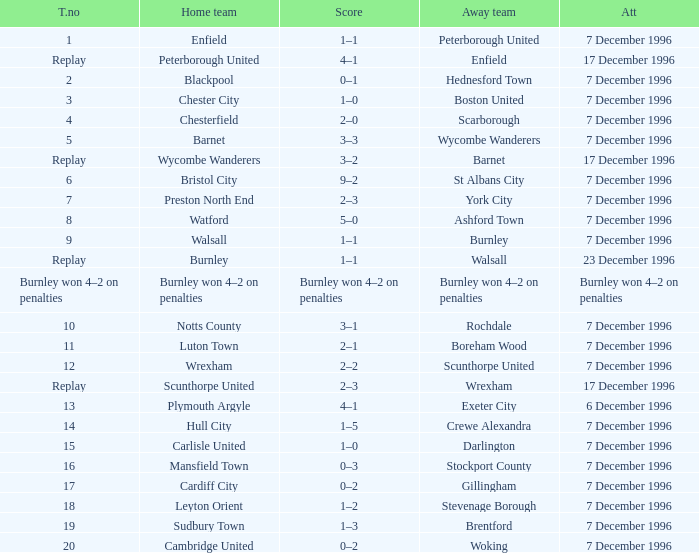What was the attendance for the home team of Walsall? 7 December 1996. Could you parse the entire table? {'header': ['T.no', 'Home team', 'Score', 'Away team', 'Att'], 'rows': [['1', 'Enfield', '1–1', 'Peterborough United', '7 December 1996'], ['Replay', 'Peterborough United', '4–1', 'Enfield', '17 December 1996'], ['2', 'Blackpool', '0–1', 'Hednesford Town', '7 December 1996'], ['3', 'Chester City', '1–0', 'Boston United', '7 December 1996'], ['4', 'Chesterfield', '2–0', 'Scarborough', '7 December 1996'], ['5', 'Barnet', '3–3', 'Wycombe Wanderers', '7 December 1996'], ['Replay', 'Wycombe Wanderers', '3–2', 'Barnet', '17 December 1996'], ['6', 'Bristol City', '9–2', 'St Albans City', '7 December 1996'], ['7', 'Preston North End', '2–3', 'York City', '7 December 1996'], ['8', 'Watford', '5–0', 'Ashford Town', '7 December 1996'], ['9', 'Walsall', '1–1', 'Burnley', '7 December 1996'], ['Replay', 'Burnley', '1–1', 'Walsall', '23 December 1996'], ['Burnley won 4–2 on penalties', 'Burnley won 4–2 on penalties', 'Burnley won 4–2 on penalties', 'Burnley won 4–2 on penalties', 'Burnley won 4–2 on penalties'], ['10', 'Notts County', '3–1', 'Rochdale', '7 December 1996'], ['11', 'Luton Town', '2–1', 'Boreham Wood', '7 December 1996'], ['12', 'Wrexham', '2–2', 'Scunthorpe United', '7 December 1996'], ['Replay', 'Scunthorpe United', '2–3', 'Wrexham', '17 December 1996'], ['13', 'Plymouth Argyle', '4–1', 'Exeter City', '6 December 1996'], ['14', 'Hull City', '1–5', 'Crewe Alexandra', '7 December 1996'], ['15', 'Carlisle United', '1–0', 'Darlington', '7 December 1996'], ['16', 'Mansfield Town', '0–3', 'Stockport County', '7 December 1996'], ['17', 'Cardiff City', '0–2', 'Gillingham', '7 December 1996'], ['18', 'Leyton Orient', '1–2', 'Stevenage Borough', '7 December 1996'], ['19', 'Sudbury Town', '1–3', 'Brentford', '7 December 1996'], ['20', 'Cambridge United', '0–2', 'Woking', '7 December 1996']]} 